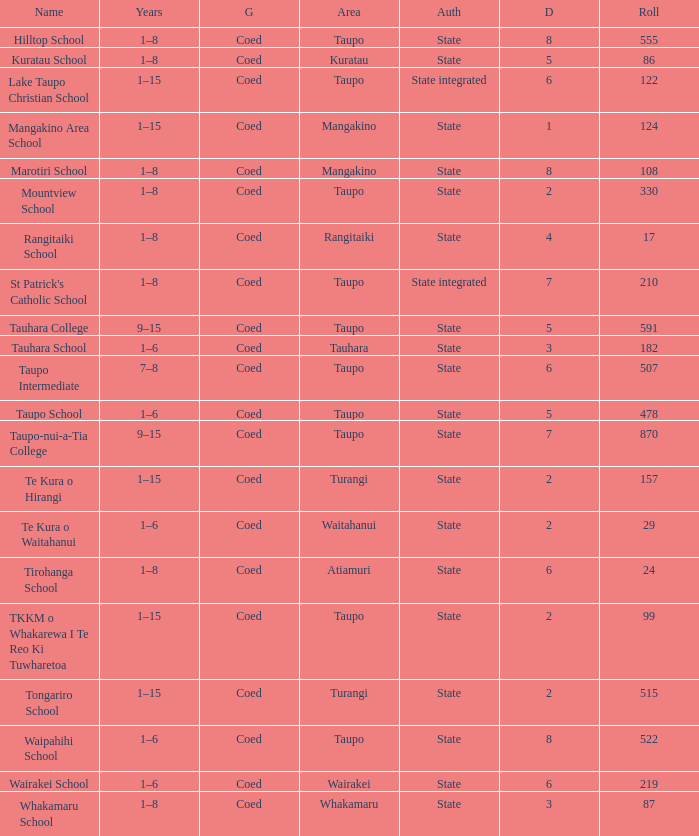Where can one find the state-run school that has an enrollment of over 157 students? Taupo, Taupo, Taupo, Tauhara, Taupo, Taupo, Taupo, Turangi, Taupo, Wairakei. 